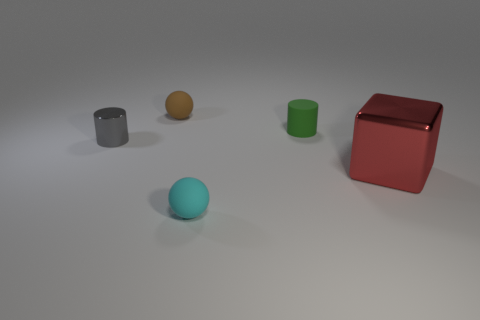Add 5 small gray things. How many objects exist? 10 Subtract all cylinders. How many objects are left? 3 Subtract 1 cyan balls. How many objects are left? 4 Subtract all matte things. Subtract all blocks. How many objects are left? 1 Add 2 tiny brown spheres. How many tiny brown spheres are left? 3 Add 3 red spheres. How many red spheres exist? 3 